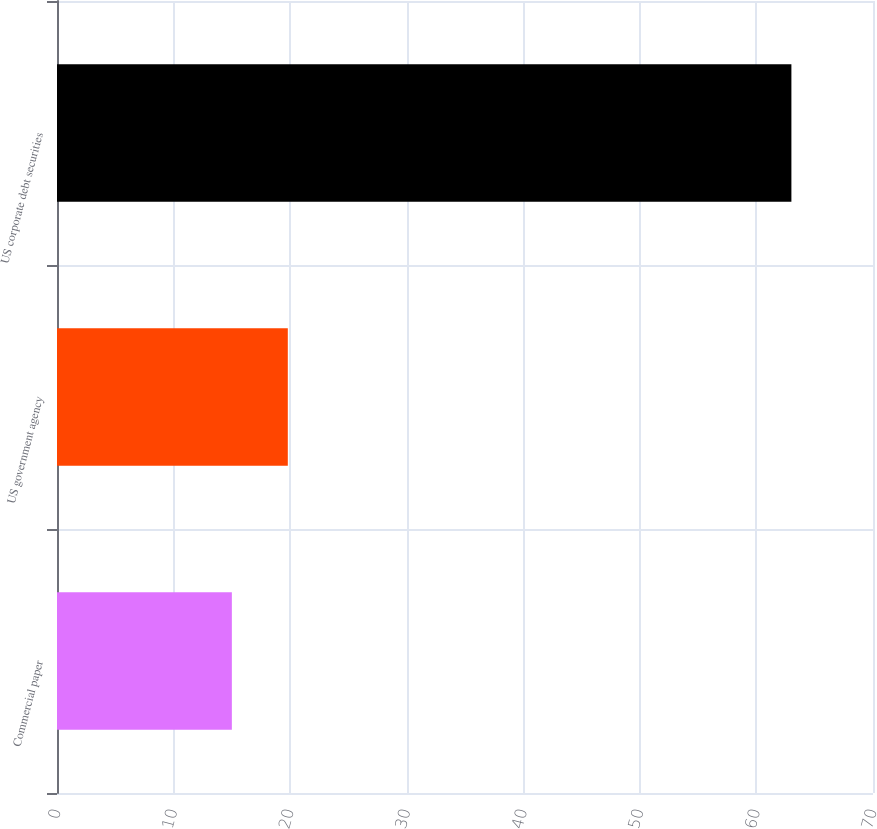<chart> <loc_0><loc_0><loc_500><loc_500><bar_chart><fcel>Commercial paper<fcel>US government agency<fcel>US corporate debt securities<nl><fcel>15<fcel>19.8<fcel>63<nl></chart> 